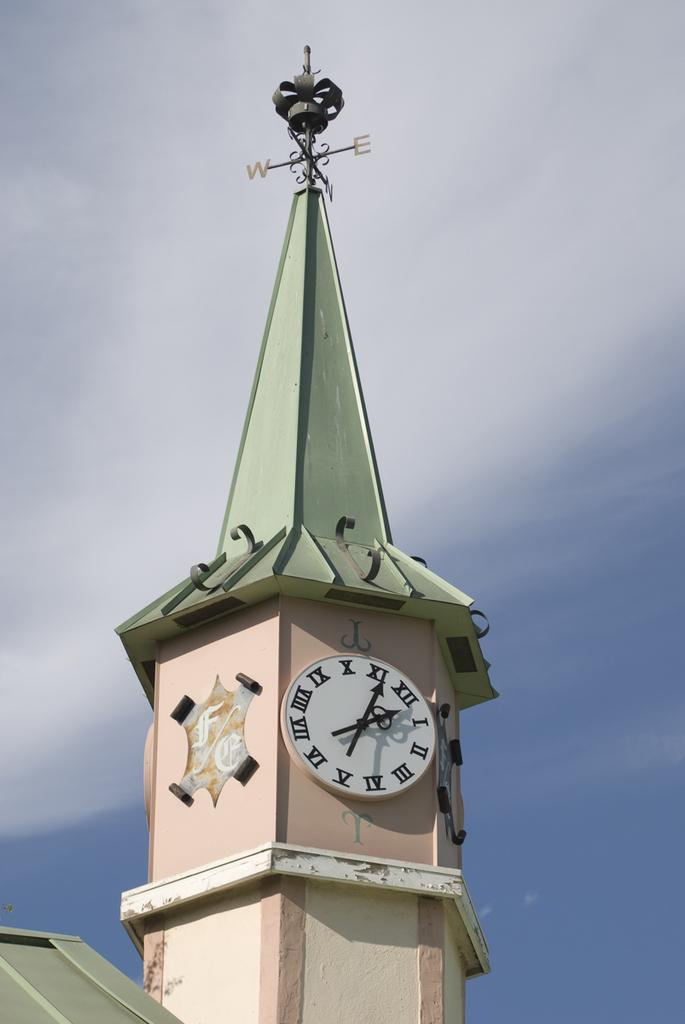<image>
Share a concise interpretation of the image provided. A clock tower showing the time 2:05 has a weather vane on top. 